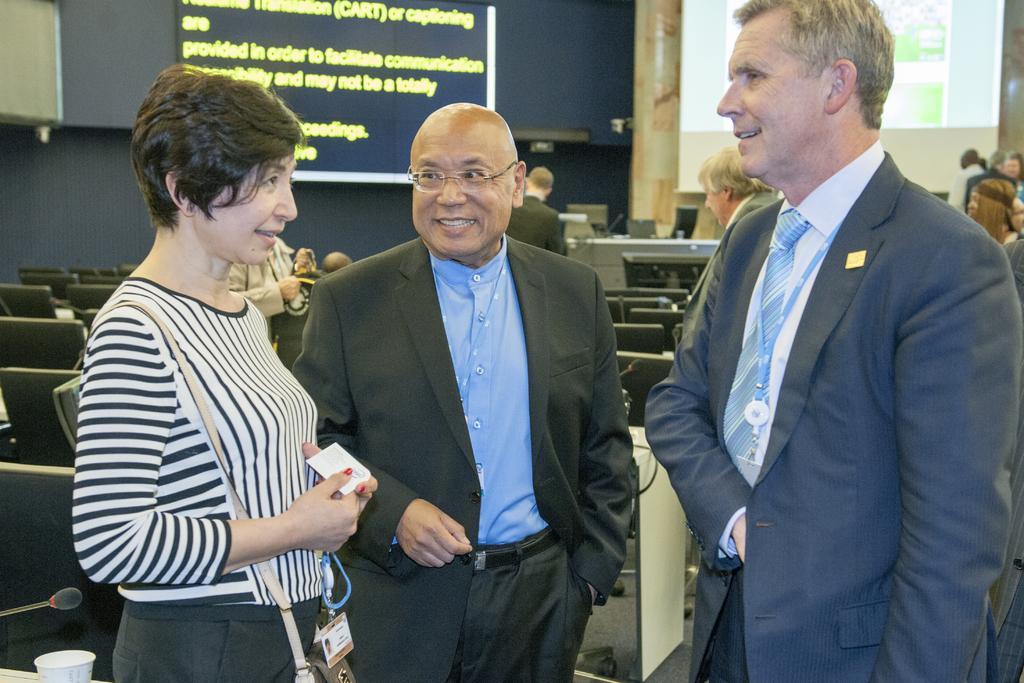Can you describe this image briefly? This picture describes about group of people, in the background we can see few chairs, microphones, hoarding and a projector screen, in the bottom left hand corner we can see a cup. 